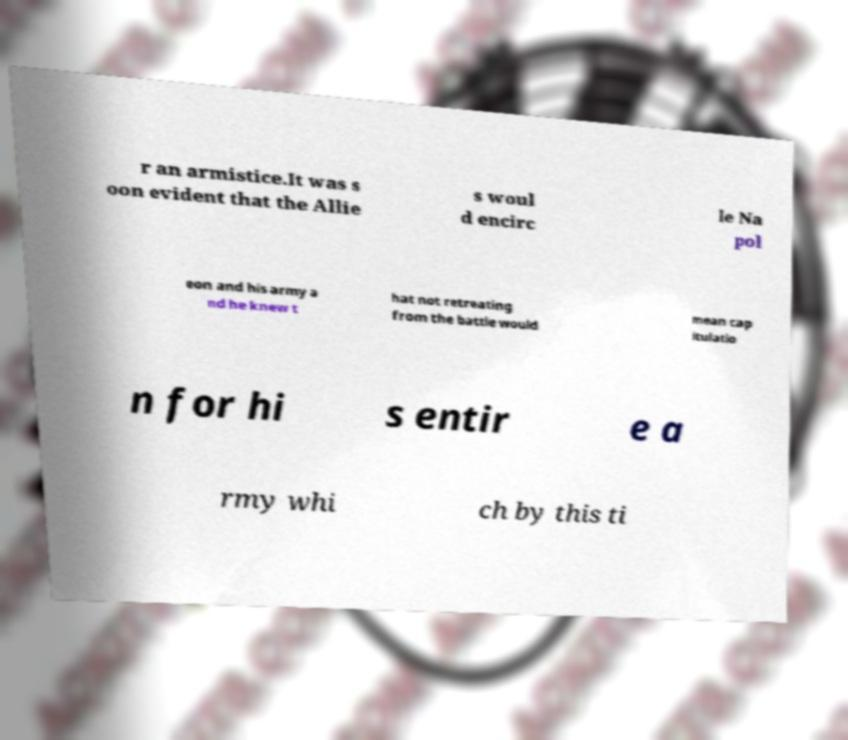Could you extract and type out the text from this image? r an armistice.It was s oon evident that the Allie s woul d encirc le Na pol eon and his army a nd he knew t hat not retreating from the battle would mean cap itulatio n for hi s entir e a rmy whi ch by this ti 